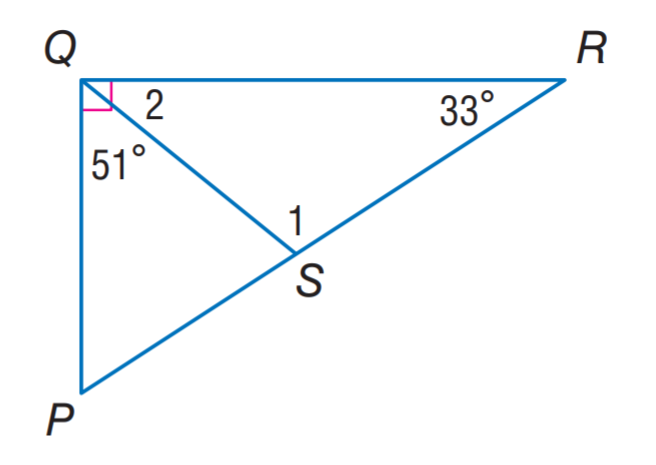Answer the mathemtical geometry problem and directly provide the correct option letter.
Question: Find m \angle 2.
Choices: A: 33 B: 39 C: 51 D: 108 B 